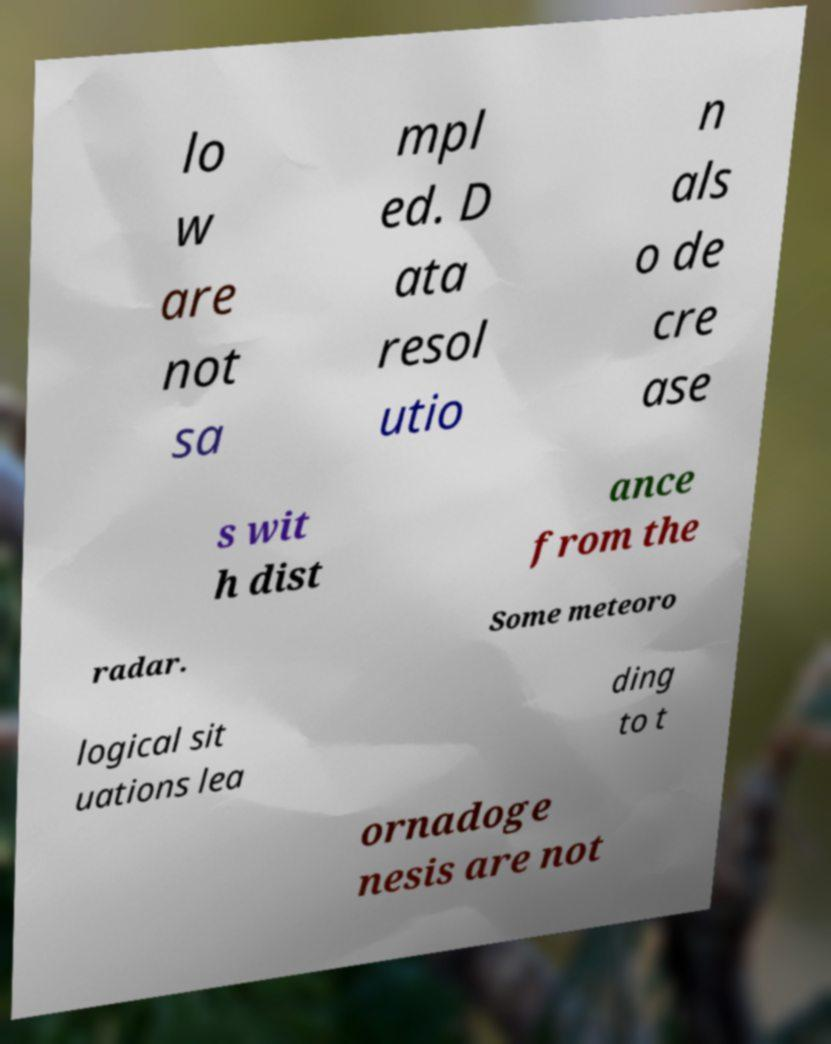Could you assist in decoding the text presented in this image and type it out clearly? lo w are not sa mpl ed. D ata resol utio n als o de cre ase s wit h dist ance from the radar. Some meteoro logical sit uations lea ding to t ornadoge nesis are not 